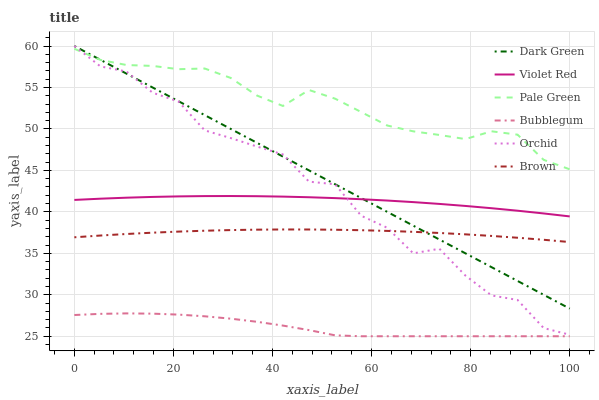Does Bubblegum have the minimum area under the curve?
Answer yes or no. Yes. Does Pale Green have the maximum area under the curve?
Answer yes or no. Yes. Does Violet Red have the minimum area under the curve?
Answer yes or no. No. Does Violet Red have the maximum area under the curve?
Answer yes or no. No. Is Dark Green the smoothest?
Answer yes or no. Yes. Is Orchid the roughest?
Answer yes or no. Yes. Is Violet Red the smoothest?
Answer yes or no. No. Is Violet Red the roughest?
Answer yes or no. No. Does Bubblegum have the lowest value?
Answer yes or no. Yes. Does Violet Red have the lowest value?
Answer yes or no. No. Does Orchid have the highest value?
Answer yes or no. Yes. Does Violet Red have the highest value?
Answer yes or no. No. Is Bubblegum less than Dark Green?
Answer yes or no. Yes. Is Dark Green greater than Bubblegum?
Answer yes or no. Yes. Does Dark Green intersect Violet Red?
Answer yes or no. Yes. Is Dark Green less than Violet Red?
Answer yes or no. No. Is Dark Green greater than Violet Red?
Answer yes or no. No. Does Bubblegum intersect Dark Green?
Answer yes or no. No. 